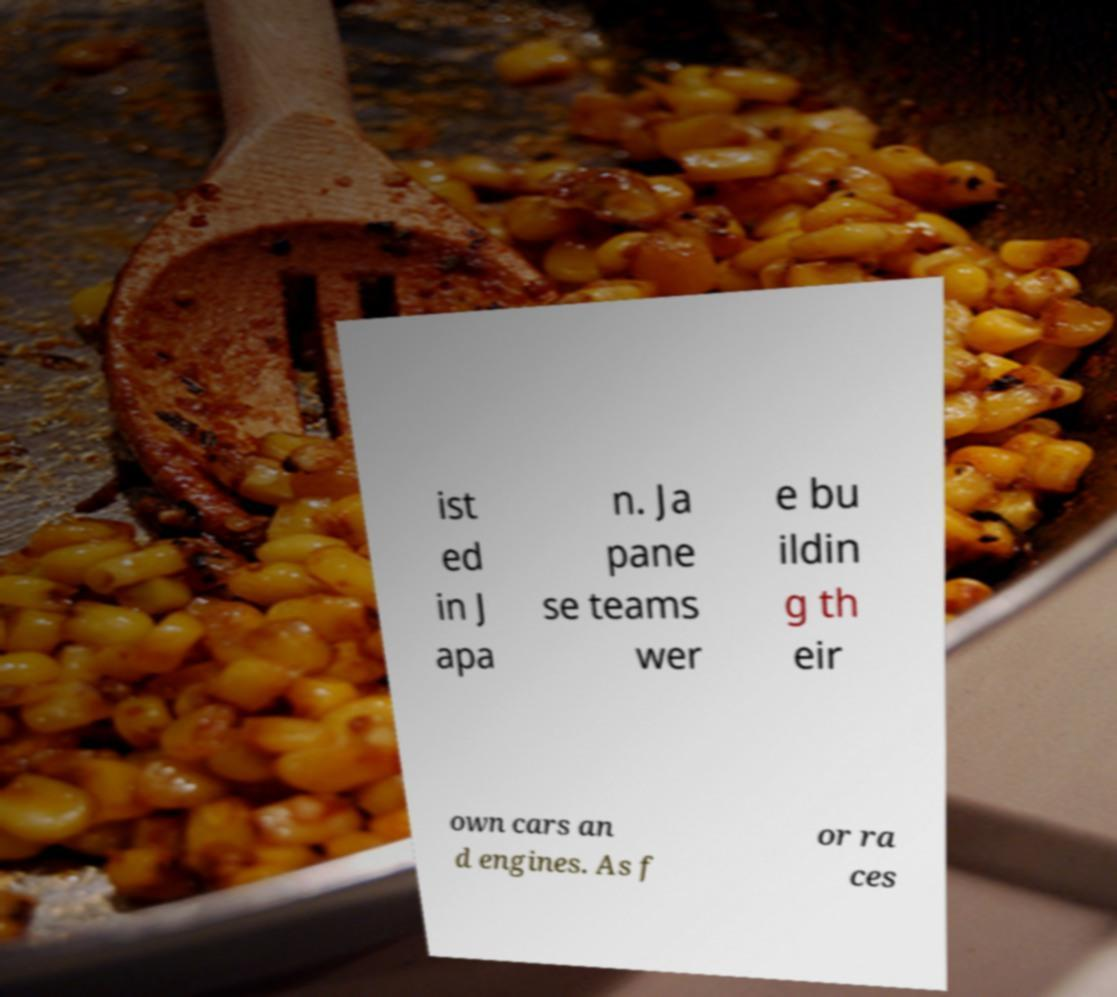For documentation purposes, I need the text within this image transcribed. Could you provide that? ist ed in J apa n. Ja pane se teams wer e bu ildin g th eir own cars an d engines. As f or ra ces 